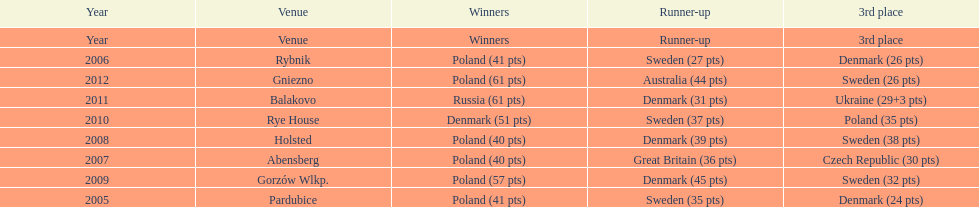After 2008 how many points total were scored by winners? 230. 